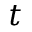Convert formula to latex. <formula><loc_0><loc_0><loc_500><loc_500>t</formula> 